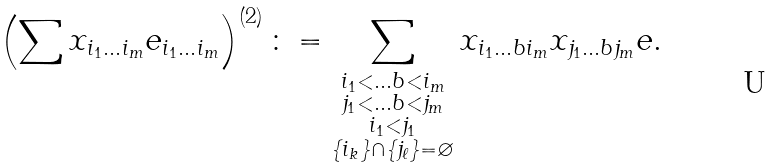<formula> <loc_0><loc_0><loc_500><loc_500>\left ( \sum x _ { i _ { 1 } \dots i _ { m } } e _ { i _ { 1 } \dots i _ { m } } \right ) ^ { ( 2 ) } \colon = \sum _ { \substack { i _ { 1 } < \dots b < i _ { m } \\ j _ { 1 } < \dots b < j _ { m } \\ i _ { 1 } < j _ { 1 } \\ \{ i _ { k } \} \cap \{ j _ { \ell } \} = \varnothing } } x _ { i _ { 1 } \dots b i _ { m } } x _ { j _ { 1 } \dots b j _ { m } } e .</formula> 